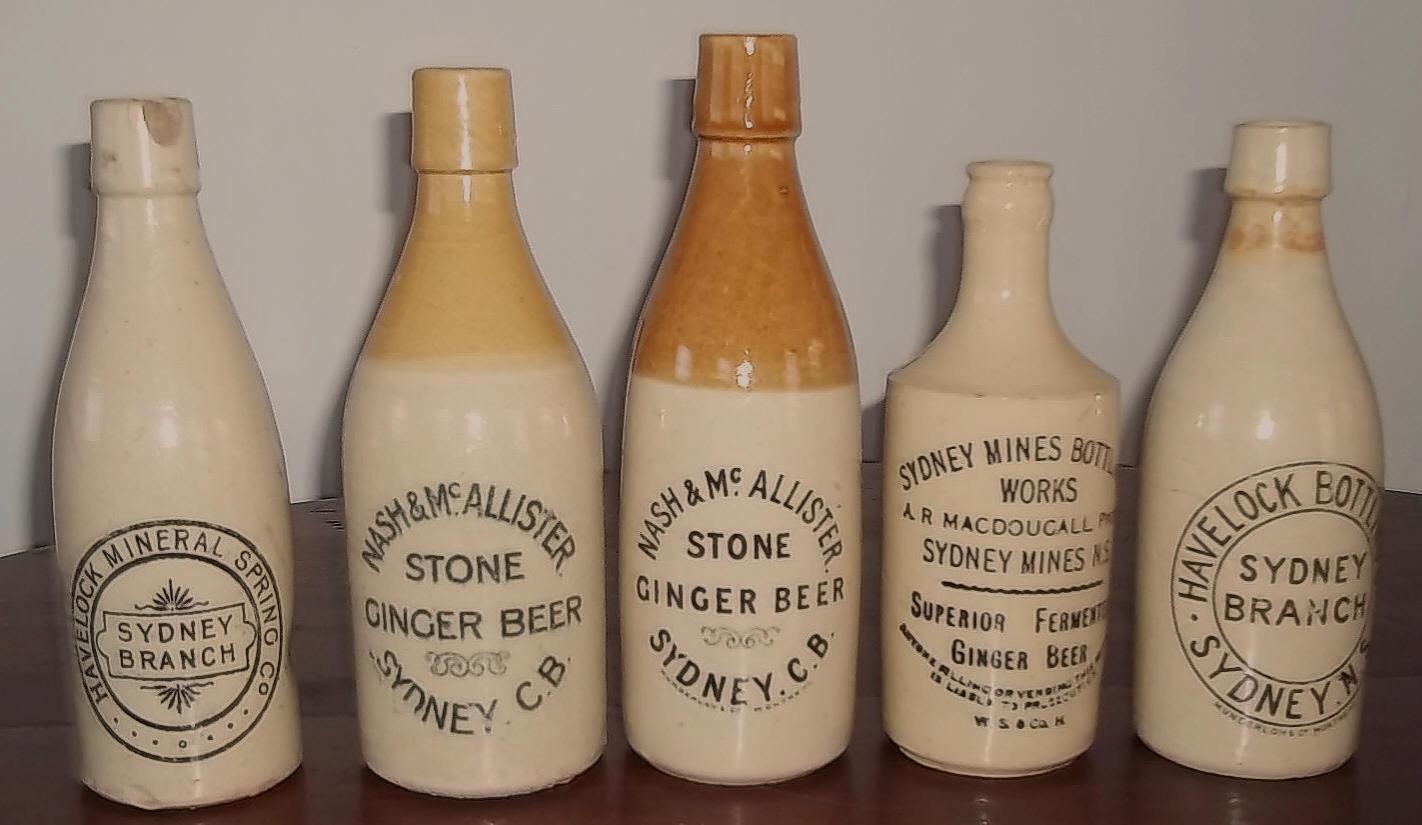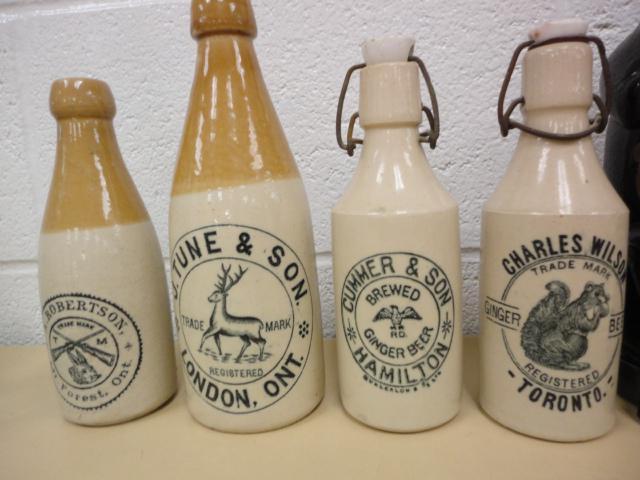The first image is the image on the left, the second image is the image on the right. Analyze the images presented: Is the assertion "There is no less than nine bottles." valid? Answer yes or no. Yes. The first image is the image on the left, the second image is the image on the right. Evaluate the accuracy of this statement regarding the images: "There are more than 8 bottles.". Is it true? Answer yes or no. Yes. 